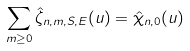Convert formula to latex. <formula><loc_0><loc_0><loc_500><loc_500>\sum _ { m \geq 0 } \hat { \zeta } _ { n , m , S , E } ( u ) = \hat { \chi } _ { n , 0 } ( u )</formula> 